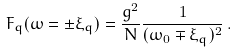<formula> <loc_0><loc_0><loc_500><loc_500>F _ { q } ( \omega = \pm \xi _ { q } ) = \frac { g ^ { 2 } } { N } \frac { 1 } { ( \omega _ { 0 } \mp \xi _ { q } ) ^ { 2 } } \, .</formula> 